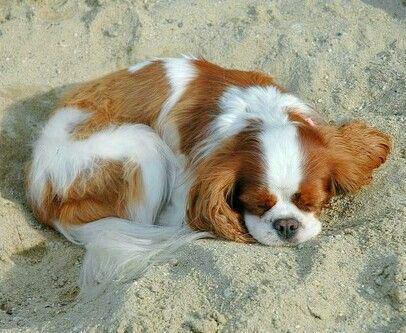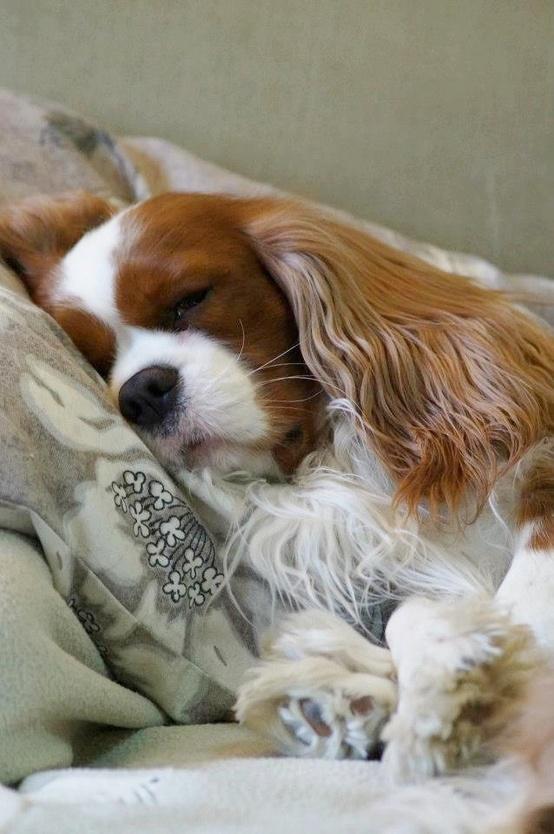The first image is the image on the left, the second image is the image on the right. Assess this claim about the two images: "There are more dogs in the image on the left than in the image on the right.". Correct or not? Answer yes or no. No. The first image is the image on the left, the second image is the image on the right. Considering the images on both sides, is "One image shows a trio of reclining puppies, with the middle one flanked by two dogs with matching coloring." valid? Answer yes or no. No. 